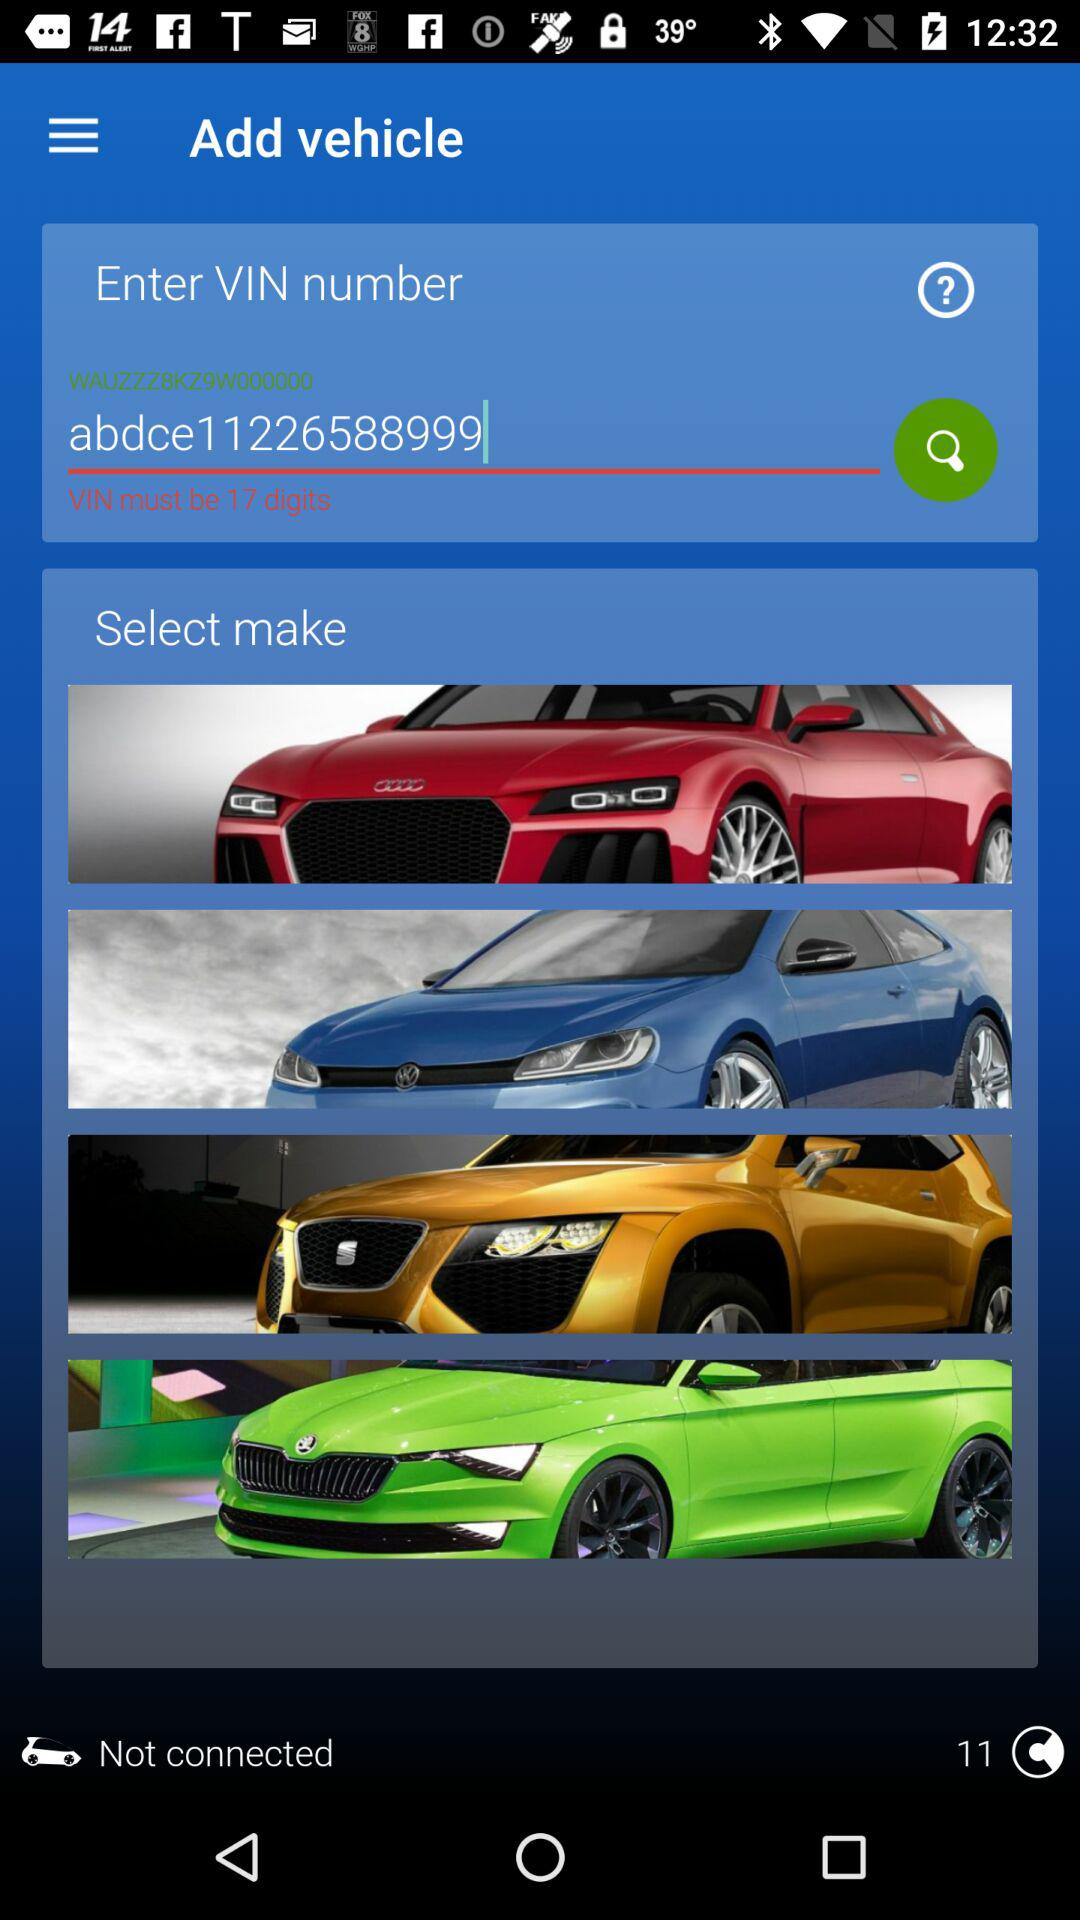What is the VIN number? The VIN number is "abdce11226588999". 